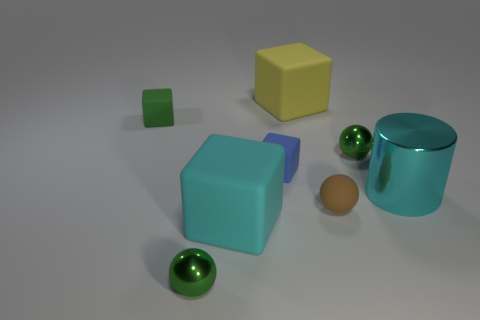Can you tell me the colors and shapes of the objects seen in this image? Certainly! In the image, we have objects in various colors and shapes. There is a large blue cube, a small green cube, a yellow cube, a cyan cylinder, and three green spheres. Each object has a distinctly smooth texture, suggesting that they are 3D models. 